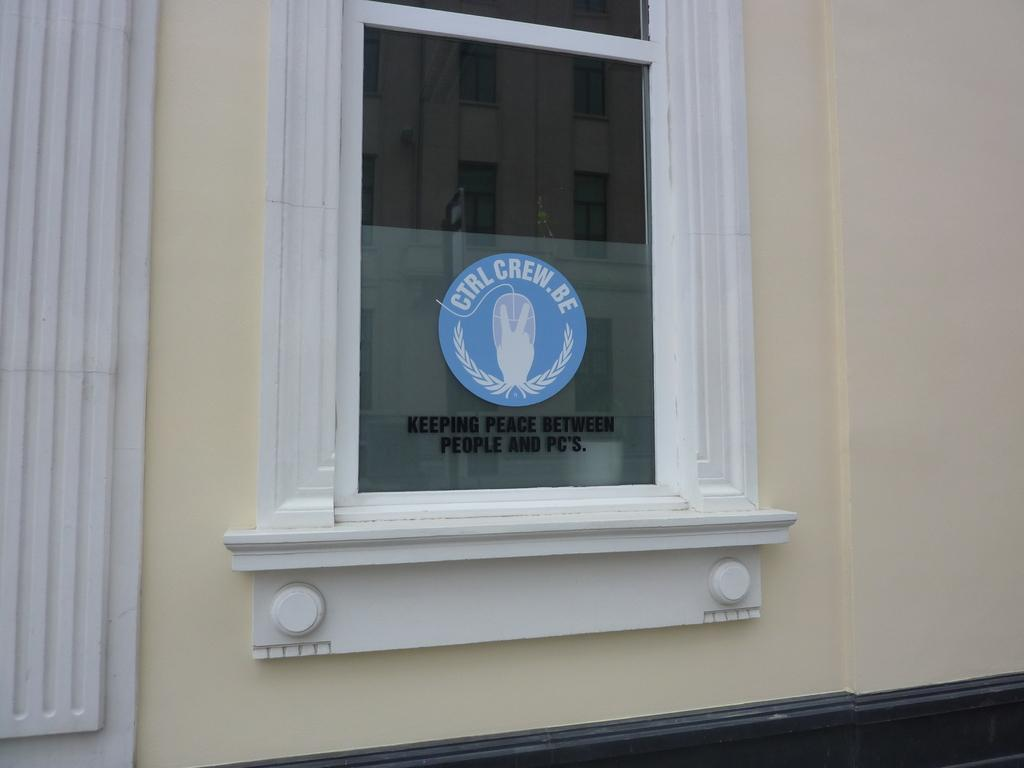What is present on the wall in the image? There is a glass placed on the wall in the image. Can you describe the glass in more detail? The glass has an emblem on it. Are there any flowers growing on the wall in the image? No, there are no flowers present on the wall in the image. 